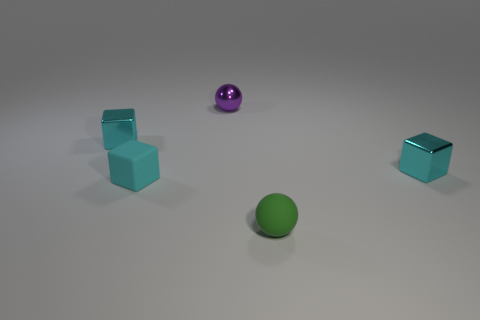If this image was part of a physics lesson, what question could you ask about these objects? An intriguing physics question could be: 'If all objects were pushed with the same force, which object would travel the farthest, and why?' This question explores concepts like friction, surface texture, and shape, which affect the objects' motion. 